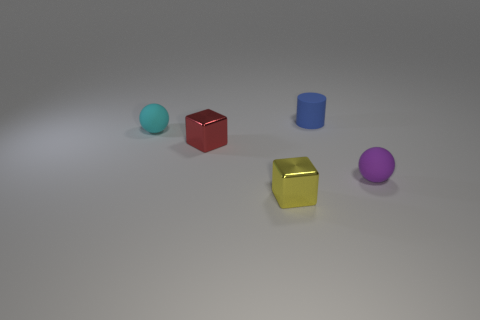Add 2 big red cylinders. How many objects exist? 7 Subtract all red cubes. How many cubes are left? 1 Subtract all balls. How many objects are left? 3 Subtract 1 cylinders. How many cylinders are left? 0 Subtract all yellow cubes. Subtract all purple cylinders. How many cubes are left? 1 Subtract all blue cylinders. How many green balls are left? 0 Subtract all small purple things. Subtract all small red objects. How many objects are left? 3 Add 5 red things. How many red things are left? 6 Add 5 tiny blue balls. How many tiny blue balls exist? 5 Subtract 0 brown cylinders. How many objects are left? 5 